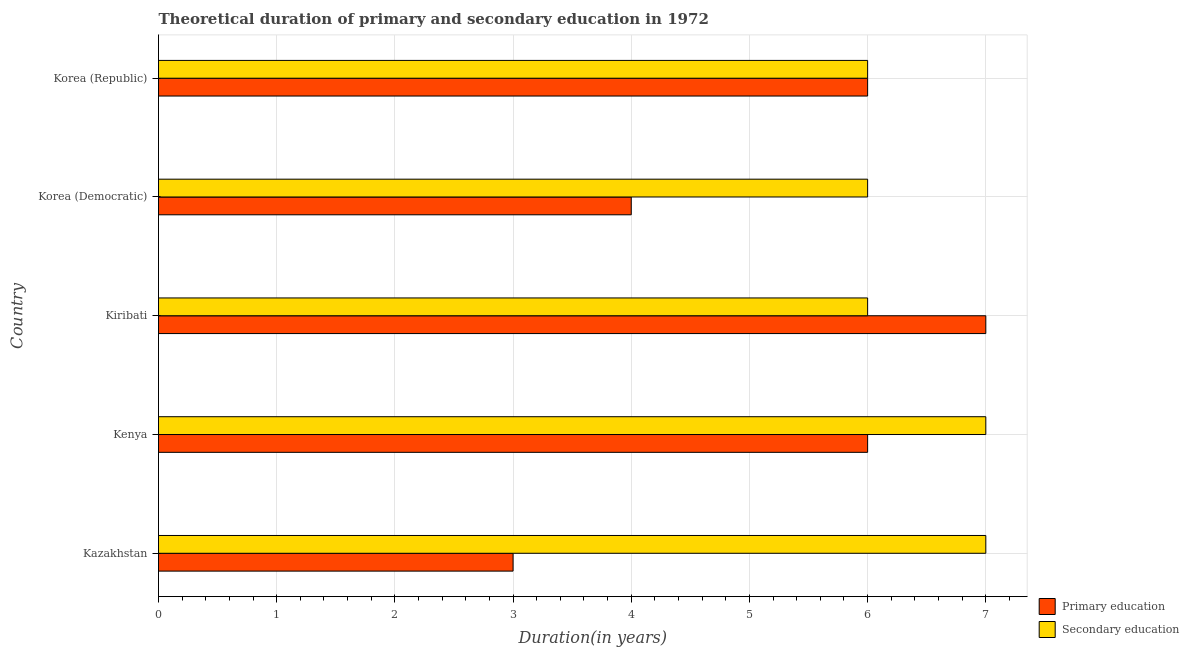How many groups of bars are there?
Ensure brevity in your answer.  5. Are the number of bars on each tick of the Y-axis equal?
Your response must be concise. Yes. How many bars are there on the 4th tick from the bottom?
Your answer should be compact. 2. What is the label of the 4th group of bars from the top?
Offer a terse response. Kenya. What is the duration of secondary education in Kazakhstan?
Keep it short and to the point. 7. Across all countries, what is the maximum duration of secondary education?
Provide a short and direct response. 7. Across all countries, what is the minimum duration of primary education?
Provide a succinct answer. 3. In which country was the duration of secondary education maximum?
Offer a very short reply. Kazakhstan. In which country was the duration of primary education minimum?
Give a very brief answer. Kazakhstan. What is the total duration of secondary education in the graph?
Ensure brevity in your answer.  32. What is the difference between the duration of secondary education in Kenya and that in Kiribati?
Provide a succinct answer. 1. What is the difference between the duration of primary education in Korea (Republic) and the duration of secondary education in Kazakhstan?
Offer a terse response. -1. What is the average duration of secondary education per country?
Offer a very short reply. 6.4. What is the difference between the duration of primary education and duration of secondary education in Kiribati?
Make the answer very short. 1. In how many countries, is the duration of secondary education greater than 0.4 years?
Your answer should be compact. 5. What is the ratio of the duration of secondary education in Kenya to that in Kiribati?
Offer a very short reply. 1.17. What is the difference between the highest and the second highest duration of primary education?
Provide a short and direct response. 1. What is the difference between the highest and the lowest duration of secondary education?
Make the answer very short. 1. What does the 1st bar from the top in Kenya represents?
Keep it short and to the point. Secondary education. How many countries are there in the graph?
Ensure brevity in your answer.  5. What is the difference between two consecutive major ticks on the X-axis?
Your answer should be very brief. 1. Are the values on the major ticks of X-axis written in scientific E-notation?
Your response must be concise. No. Does the graph contain any zero values?
Offer a very short reply. No. Does the graph contain grids?
Your answer should be compact. Yes. Where does the legend appear in the graph?
Give a very brief answer. Bottom right. How many legend labels are there?
Your response must be concise. 2. How are the legend labels stacked?
Offer a very short reply. Vertical. What is the title of the graph?
Offer a very short reply. Theoretical duration of primary and secondary education in 1972. What is the label or title of the X-axis?
Your answer should be very brief. Duration(in years). What is the Duration(in years) in Secondary education in Kiribati?
Offer a very short reply. 6. What is the Duration(in years) in Primary education in Korea (Democratic)?
Provide a short and direct response. 4. What is the Duration(in years) of Secondary education in Korea (Democratic)?
Give a very brief answer. 6. What is the Duration(in years) in Primary education in Korea (Republic)?
Make the answer very short. 6. What is the Duration(in years) in Secondary education in Korea (Republic)?
Keep it short and to the point. 6. Across all countries, what is the maximum Duration(in years) in Primary education?
Provide a short and direct response. 7. What is the difference between the Duration(in years) of Primary education in Kazakhstan and that in Kiribati?
Make the answer very short. -4. What is the difference between the Duration(in years) in Secondary education in Kazakhstan and that in Korea (Democratic)?
Ensure brevity in your answer.  1. What is the difference between the Duration(in years) in Primary education in Kazakhstan and that in Korea (Republic)?
Provide a short and direct response. -3. What is the difference between the Duration(in years) of Secondary education in Kazakhstan and that in Korea (Republic)?
Keep it short and to the point. 1. What is the difference between the Duration(in years) in Primary education in Kenya and that in Korea (Democratic)?
Ensure brevity in your answer.  2. What is the difference between the Duration(in years) in Secondary education in Kiribati and that in Korea (Democratic)?
Give a very brief answer. 0. What is the difference between the Duration(in years) in Primary education in Kiribati and that in Korea (Republic)?
Provide a short and direct response. 1. What is the difference between the Duration(in years) of Primary education in Korea (Democratic) and that in Korea (Republic)?
Your answer should be compact. -2. What is the difference between the Duration(in years) in Secondary education in Korea (Democratic) and that in Korea (Republic)?
Provide a succinct answer. 0. What is the difference between the Duration(in years) in Primary education in Kazakhstan and the Duration(in years) in Secondary education in Kenya?
Make the answer very short. -4. What is the difference between the Duration(in years) in Primary education in Kazakhstan and the Duration(in years) in Secondary education in Kiribati?
Your response must be concise. -3. What is the difference between the Duration(in years) in Primary education in Kazakhstan and the Duration(in years) in Secondary education in Korea (Democratic)?
Your answer should be compact. -3. What is the difference between the Duration(in years) of Primary education in Kiribati and the Duration(in years) of Secondary education in Korea (Democratic)?
Your answer should be compact. 1. What is the difference between the Duration(in years) of Primary education in Kiribati and the Duration(in years) of Secondary education in Korea (Republic)?
Offer a very short reply. 1. What is the difference between the Duration(in years) in Primary education in Korea (Democratic) and the Duration(in years) in Secondary education in Korea (Republic)?
Provide a short and direct response. -2. What is the average Duration(in years) in Primary education per country?
Make the answer very short. 5.2. What is the average Duration(in years) of Secondary education per country?
Your answer should be very brief. 6.4. What is the difference between the Duration(in years) in Primary education and Duration(in years) in Secondary education in Korea (Democratic)?
Provide a succinct answer. -2. What is the difference between the Duration(in years) in Primary education and Duration(in years) in Secondary education in Korea (Republic)?
Offer a terse response. 0. What is the ratio of the Duration(in years) of Primary education in Kazakhstan to that in Kenya?
Offer a terse response. 0.5. What is the ratio of the Duration(in years) of Secondary education in Kazakhstan to that in Kenya?
Make the answer very short. 1. What is the ratio of the Duration(in years) in Primary education in Kazakhstan to that in Kiribati?
Keep it short and to the point. 0.43. What is the ratio of the Duration(in years) in Primary education in Kazakhstan to that in Korea (Republic)?
Your answer should be very brief. 0.5. What is the ratio of the Duration(in years) of Secondary education in Kazakhstan to that in Korea (Republic)?
Provide a succinct answer. 1.17. What is the ratio of the Duration(in years) in Primary education in Kenya to that in Kiribati?
Your answer should be very brief. 0.86. What is the ratio of the Duration(in years) in Primary education in Kenya to that in Korea (Democratic)?
Provide a succinct answer. 1.5. What is the ratio of the Duration(in years) in Secondary education in Kenya to that in Korea (Democratic)?
Provide a succinct answer. 1.17. What is the ratio of the Duration(in years) in Primary education in Kenya to that in Korea (Republic)?
Your answer should be compact. 1. What is the ratio of the Duration(in years) in Secondary education in Kenya to that in Korea (Republic)?
Your response must be concise. 1.17. What is the ratio of the Duration(in years) of Primary education in Korea (Democratic) to that in Korea (Republic)?
Offer a very short reply. 0.67. What is the difference between the highest and the second highest Duration(in years) of Secondary education?
Give a very brief answer. 0. What is the difference between the highest and the lowest Duration(in years) of Primary education?
Keep it short and to the point. 4. What is the difference between the highest and the lowest Duration(in years) in Secondary education?
Keep it short and to the point. 1. 